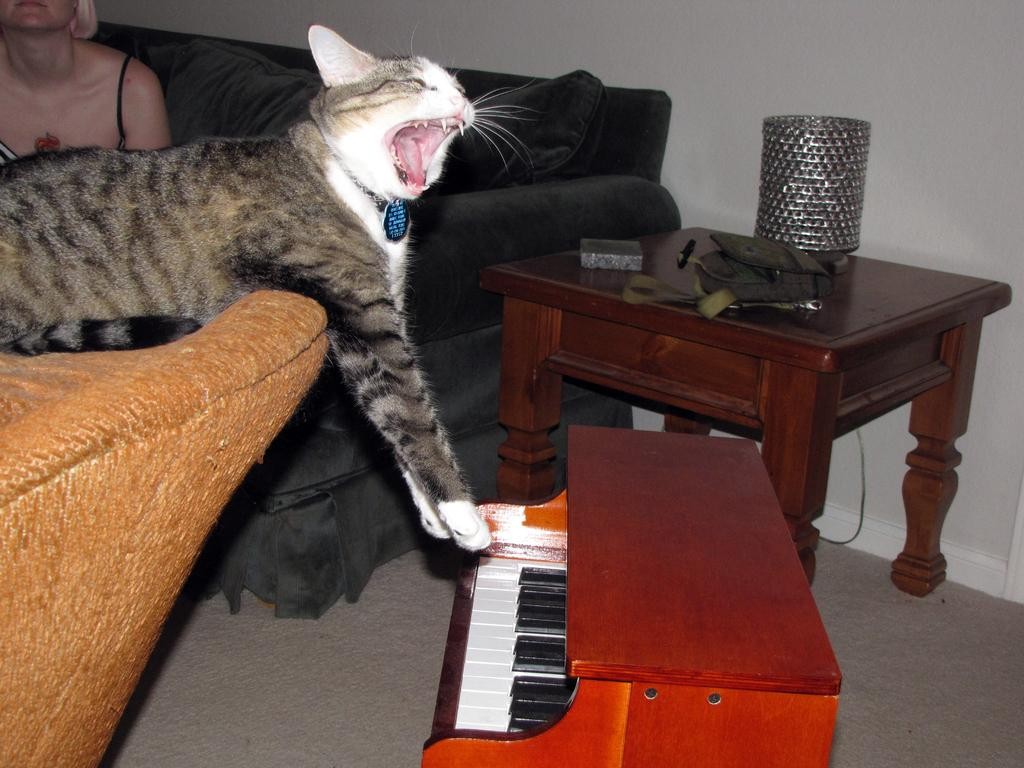What type of animal is in the image? There is a cat in the image. Who or what else is present in the image? There is a person and a musical instrument in the image. What type of furniture is in the image? There is a sofa in the image. What type of vein is visible on the cat's paw in the image? There is no vein visible on the cat's paw in the image, as the image does not show the cat's paw or any veins. 